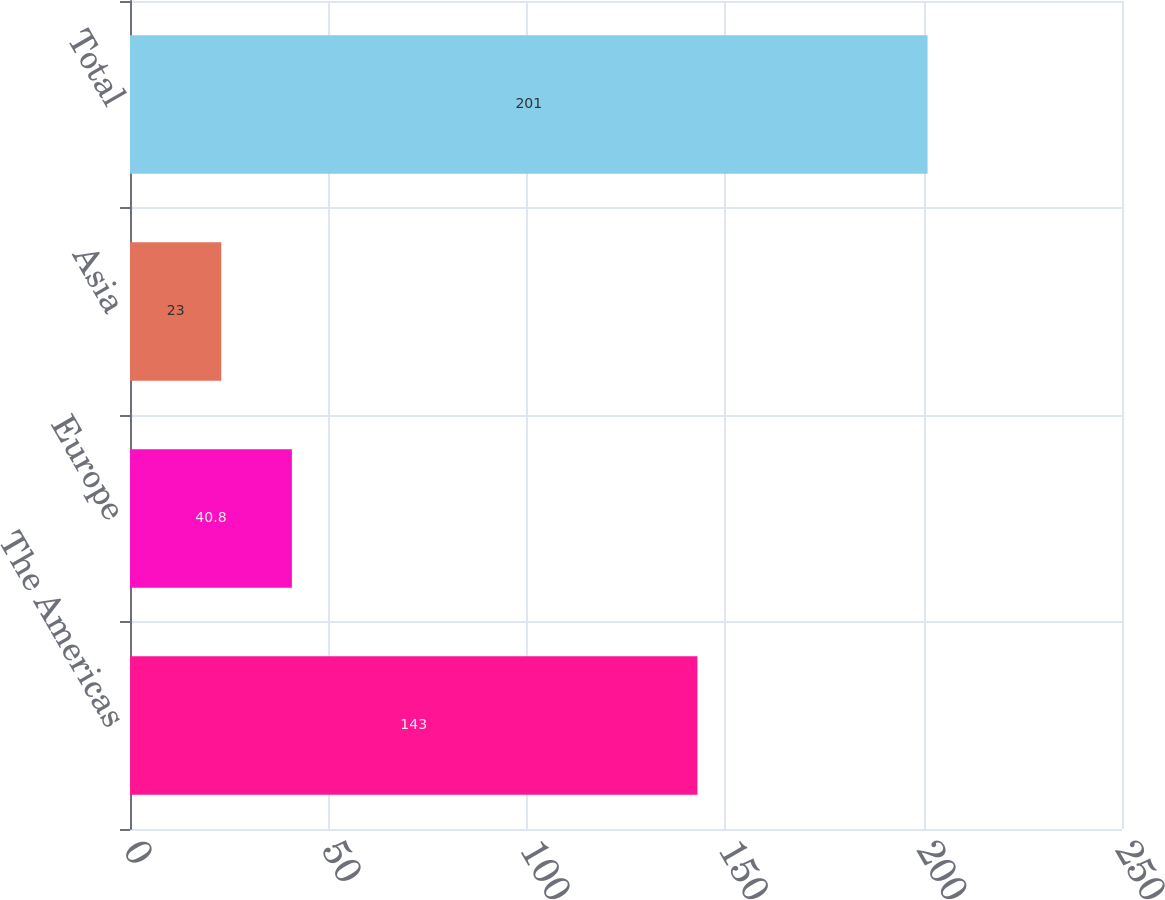Convert chart. <chart><loc_0><loc_0><loc_500><loc_500><bar_chart><fcel>The Americas<fcel>Europe<fcel>Asia<fcel>Total<nl><fcel>143<fcel>40.8<fcel>23<fcel>201<nl></chart> 